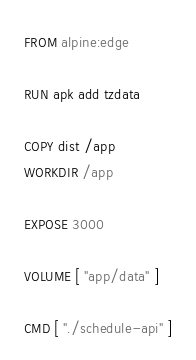<code> <loc_0><loc_0><loc_500><loc_500><_Dockerfile_>FROM alpine:edge

RUN apk add tzdata

COPY dist /app
WORKDIR /app

EXPOSE 3000

VOLUME [ "app/data" ]

CMD [ "./schedule-api" ]</code> 